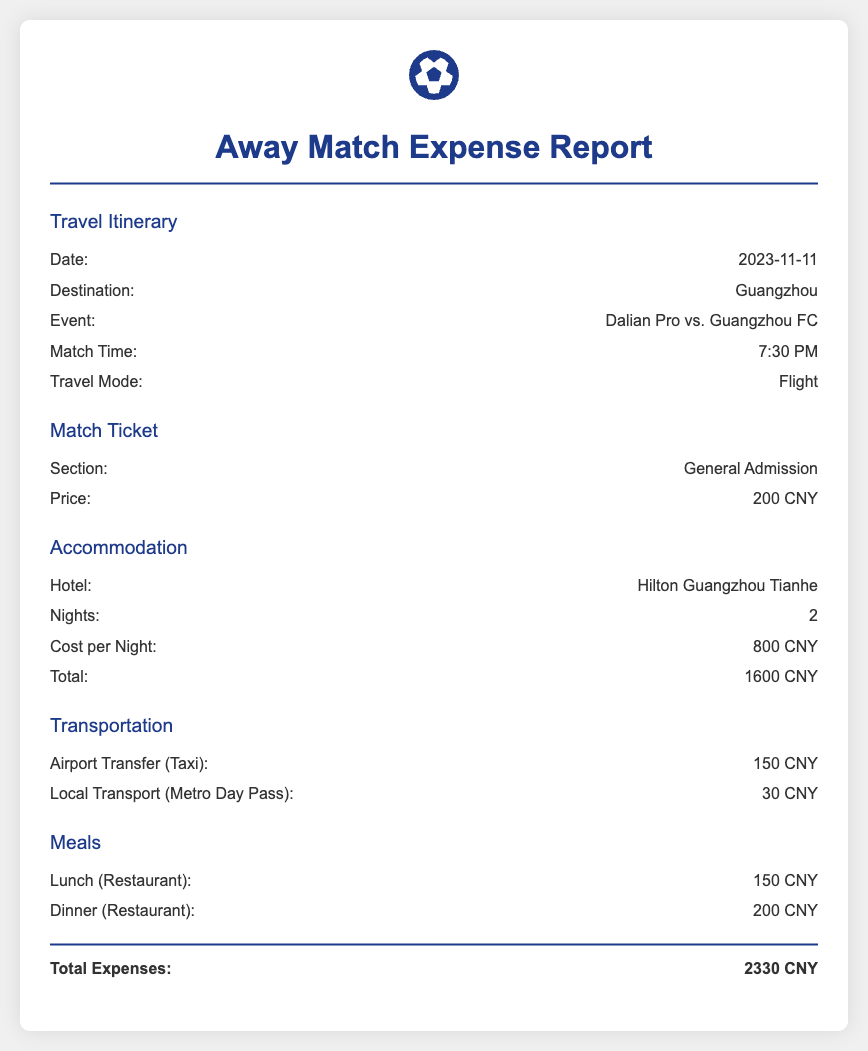What is the match date? The match date is specified in the travel itinerary section as November 11, 2023.
Answer: 2023-11-11 What is the destination for the away match? The destination for the away match is mentioned in the travel itinerary section.
Answer: Guangzhou How much does the match ticket cost? The cost of the match ticket is provided in the match ticket section.
Answer: 200 CNY What is the total accommodation cost? The total accommodation cost is calculated from the cost per night and the number of nights stayed, as stated in the accommodation section.
Answer: 1600 CNY What is the price of local transport? The price of local transport is detailed in the transportation section of the report.
Answer: 30 CNY What transportation mode will be used to travel to the match? The travel mode is listed in the travel itinerary section.
Answer: Flight How many nights will the stay be at the hotel? The number of nights is stated in the accommodation section.
Answer: 2 What is the total expense for the trip? The total expenses are summed up at the end of the document.
Answer: 2330 CNY What is the name of the hotel where accommodation is booked? The hotel name is mentioned in the accommodation section.
Answer: Hilton Guangzhou Tianhe 